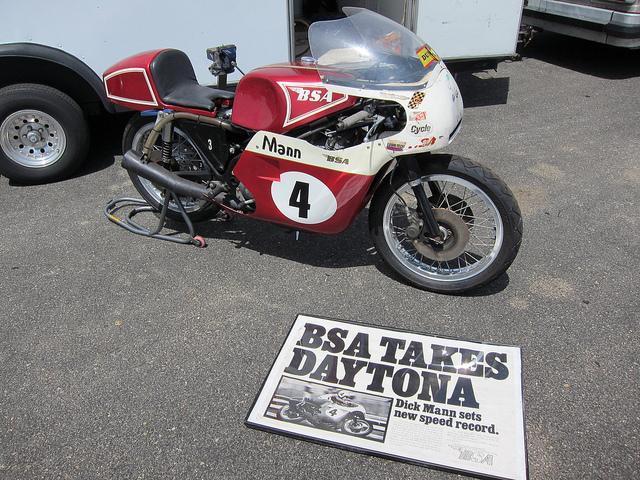How many trucks are there?
Give a very brief answer. 1. How many women pictured?
Give a very brief answer. 0. 